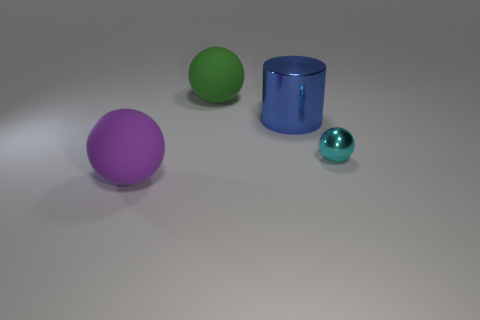The big ball that is made of the same material as the large green thing is what color?
Offer a terse response. Purple. Are there more small cyan shiny things than large cyan metallic cubes?
Provide a short and direct response. Yes. How many objects are objects that are behind the small shiny ball or small yellow metallic cylinders?
Make the answer very short. 2. Is there a gray shiny cube that has the same size as the metal cylinder?
Keep it short and to the point. No. Are there fewer large things than small metallic objects?
Keep it short and to the point. No. How many blocks are big purple objects or metallic things?
Provide a short and direct response. 0. How many large matte things are the same color as the small object?
Offer a terse response. 0. How big is the object that is both to the right of the big green matte object and to the left of the metal sphere?
Keep it short and to the point. Large. Is the number of purple rubber objects that are right of the big purple sphere less than the number of big blue spheres?
Your answer should be compact. No. Is the large purple object made of the same material as the blue thing?
Provide a short and direct response. No. 